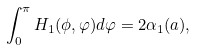<formula> <loc_0><loc_0><loc_500><loc_500>\int _ { 0 } ^ { \pi } H _ { 1 } ( \phi , \varphi ) d \varphi = 2 \alpha _ { 1 } ( a ) ,</formula> 